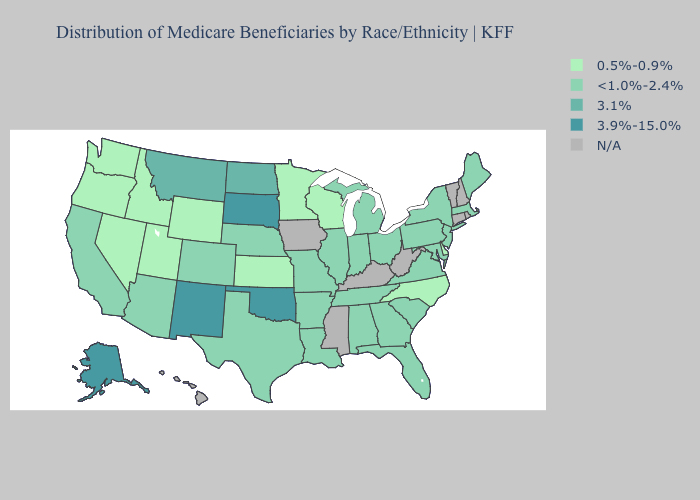Which states have the highest value in the USA?
Concise answer only. Alaska, New Mexico, Oklahoma, South Dakota. Name the states that have a value in the range 3.9%-15.0%?
Quick response, please. Alaska, New Mexico, Oklahoma, South Dakota. Which states have the lowest value in the South?
Be succinct. Delaware, North Carolina. What is the value of New York?
Write a very short answer. <1.0%-2.4%. How many symbols are there in the legend?
Concise answer only. 5. Does Kansas have the lowest value in the MidWest?
Answer briefly. Yes. What is the value of Iowa?
Answer briefly. N/A. What is the value of Maryland?
Quick response, please. <1.0%-2.4%. What is the value of Virginia?
Concise answer only. <1.0%-2.4%. Does the first symbol in the legend represent the smallest category?
Concise answer only. Yes. What is the value of North Carolina?
Answer briefly. 0.5%-0.9%. Does the map have missing data?
Concise answer only. Yes. Name the states that have a value in the range <1.0%-2.4%?
Be succinct. Alabama, Arizona, Arkansas, California, Colorado, Florida, Georgia, Illinois, Indiana, Louisiana, Maine, Maryland, Massachusetts, Michigan, Missouri, Nebraska, New Jersey, New York, Ohio, Pennsylvania, South Carolina, Tennessee, Texas, Virginia. How many symbols are there in the legend?
Write a very short answer. 5. Does the first symbol in the legend represent the smallest category?
Give a very brief answer. Yes. 